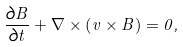<formula> <loc_0><loc_0><loc_500><loc_500>\frac { \partial B } { \partial t } + \nabla \times \left ( v \times B \right ) = 0 ,</formula> 